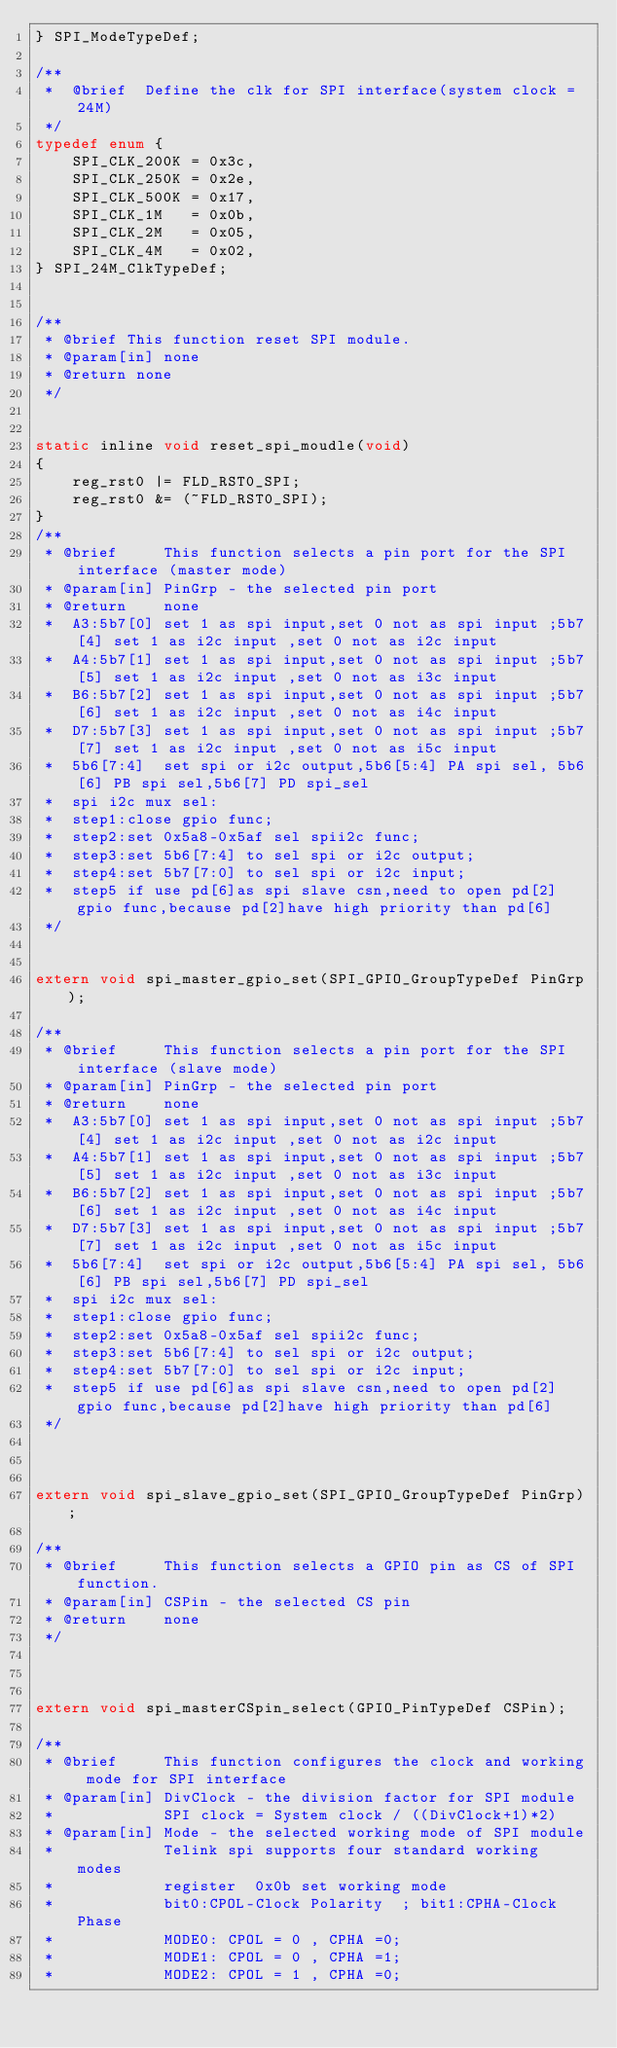Convert code to text. <code><loc_0><loc_0><loc_500><loc_500><_C_>} SPI_ModeTypeDef;

/**
 *  @brief  Define the clk for SPI interface(system clock = 24M)
 */
typedef enum {
    SPI_CLK_200K = 0x3c,
    SPI_CLK_250K = 0x2e,
    SPI_CLK_500K = 0x17,
    SPI_CLK_1M   = 0x0b,
    SPI_CLK_2M   = 0x05,
    SPI_CLK_4M   = 0x02,
} SPI_24M_ClkTypeDef;


/**
 * @brief This function reset SPI module.
 * @param[in] none
 * @return none
 */


static inline void reset_spi_moudle(void)
{
	reg_rst0 |= FLD_RST0_SPI;
	reg_rst0 &= (~FLD_RST0_SPI);
}
/**
 * @brief     This function selects a pin port for the SPI interface (master mode)
 * @param[in] PinGrp - the selected pin port
 * @return    none
 *  A3:5b7[0] set 1 as spi input,set 0 not as spi input ;5b7[4] set 1 as i2c input ,set 0 not as i2c input
 *	A4:5b7[1] set 1 as spi input,set 0 not as spi input ;5b7[5] set 1 as i2c input ,set 0 not as i3c input
 *	B6:5b7[2] set 1 as spi input,set 0 not as spi input ;5b7[6] set 1 as i2c input ,set 0 not as i4c input
 *	D7:5b7[3] set 1 as spi input,set 0 not as spi input ;5b7[7] set 1 as i2c input ,set 0 not as i5c input
 *	5b6[7:4]  set spi or i2c output,5b6[5:4] PA spi sel, 5b6[6] PB spi sel,5b6[7] PD spi_sel
 *	spi i2c mux sel:
 *	step1:close gpio func;
 *	step2:set 0x5a8-0x5af sel spii2c func;
 *	step3:set 5b6[7:4] to sel spi or i2c output;
 *	step4:set 5b7[7:0] to sel spi or i2c input;
 *	step5 if use pd[6]as spi slave csn,need to open pd[2] gpio func,because pd[2]have high priority than pd[6]
 */


extern void spi_master_gpio_set(SPI_GPIO_GroupTypeDef PinGrp);

/**
 * @brief     This function selects a pin port for the SPI interface (slave mode)
 * @param[in] PinGrp - the selected pin port
 * @return    none
 *  A3:5b7[0] set 1 as spi input,set 0 not as spi input ;5b7[4] set 1 as i2c input ,set 0 not as i2c input
 *	A4:5b7[1] set 1 as spi input,set 0 not as spi input ;5b7[5] set 1 as i2c input ,set 0 not as i3c input
 *	B6:5b7[2] set 1 as spi input,set 0 not as spi input ;5b7[6] set 1 as i2c input ,set 0 not as i4c input
 *	D7:5b7[3] set 1 as spi input,set 0 not as spi input ;5b7[7] set 1 as i2c input ,set 0 not as i5c input
 *	5b6[7:4]  set spi or i2c output,5b6[5:4] PA spi sel, 5b6[6] PB spi sel,5b6[7] PD spi_sel
 *	spi i2c mux sel:
 *	step1:close gpio func;
 *	step2:set 0x5a8-0x5af sel spii2c func;
 *	step3:set 5b6[7:4] to sel spi or i2c output;
 *	step4:set 5b7[7:0] to sel spi or i2c input;
 *	step5 if use pd[6]as spi slave csn,need to open pd[2] gpio func,because pd[2]have high priority than pd[6]
 */



extern void spi_slave_gpio_set(SPI_GPIO_GroupTypeDef PinGrp);

/**
 * @brief     This function selects a GPIO pin as CS of SPI function.
 * @param[in] CSPin - the selected CS pin
 * @return    none
 */



extern void spi_masterCSpin_select(GPIO_PinTypeDef CSPin);

/**
 * @brief     This function configures the clock and working mode for SPI interface
 * @param[in] DivClock - the division factor for SPI module
 *            SPI clock = System clock / ((DivClock+1)*2)
 * @param[in] Mode - the selected working mode of SPI module
 *            Telink spi supports four standard working modes
 *            register  0x0b set working mode
 *            bit0:CPOL-Clock Polarity  ; bit1:CPHA-Clock Phase
 *            MODE0: CPOL = 0 , CPHA =0;
 *            MODE1: CPOL = 0 , CPHA =1;
 *            MODE2: CPOL = 1 , CPHA =0;</code> 